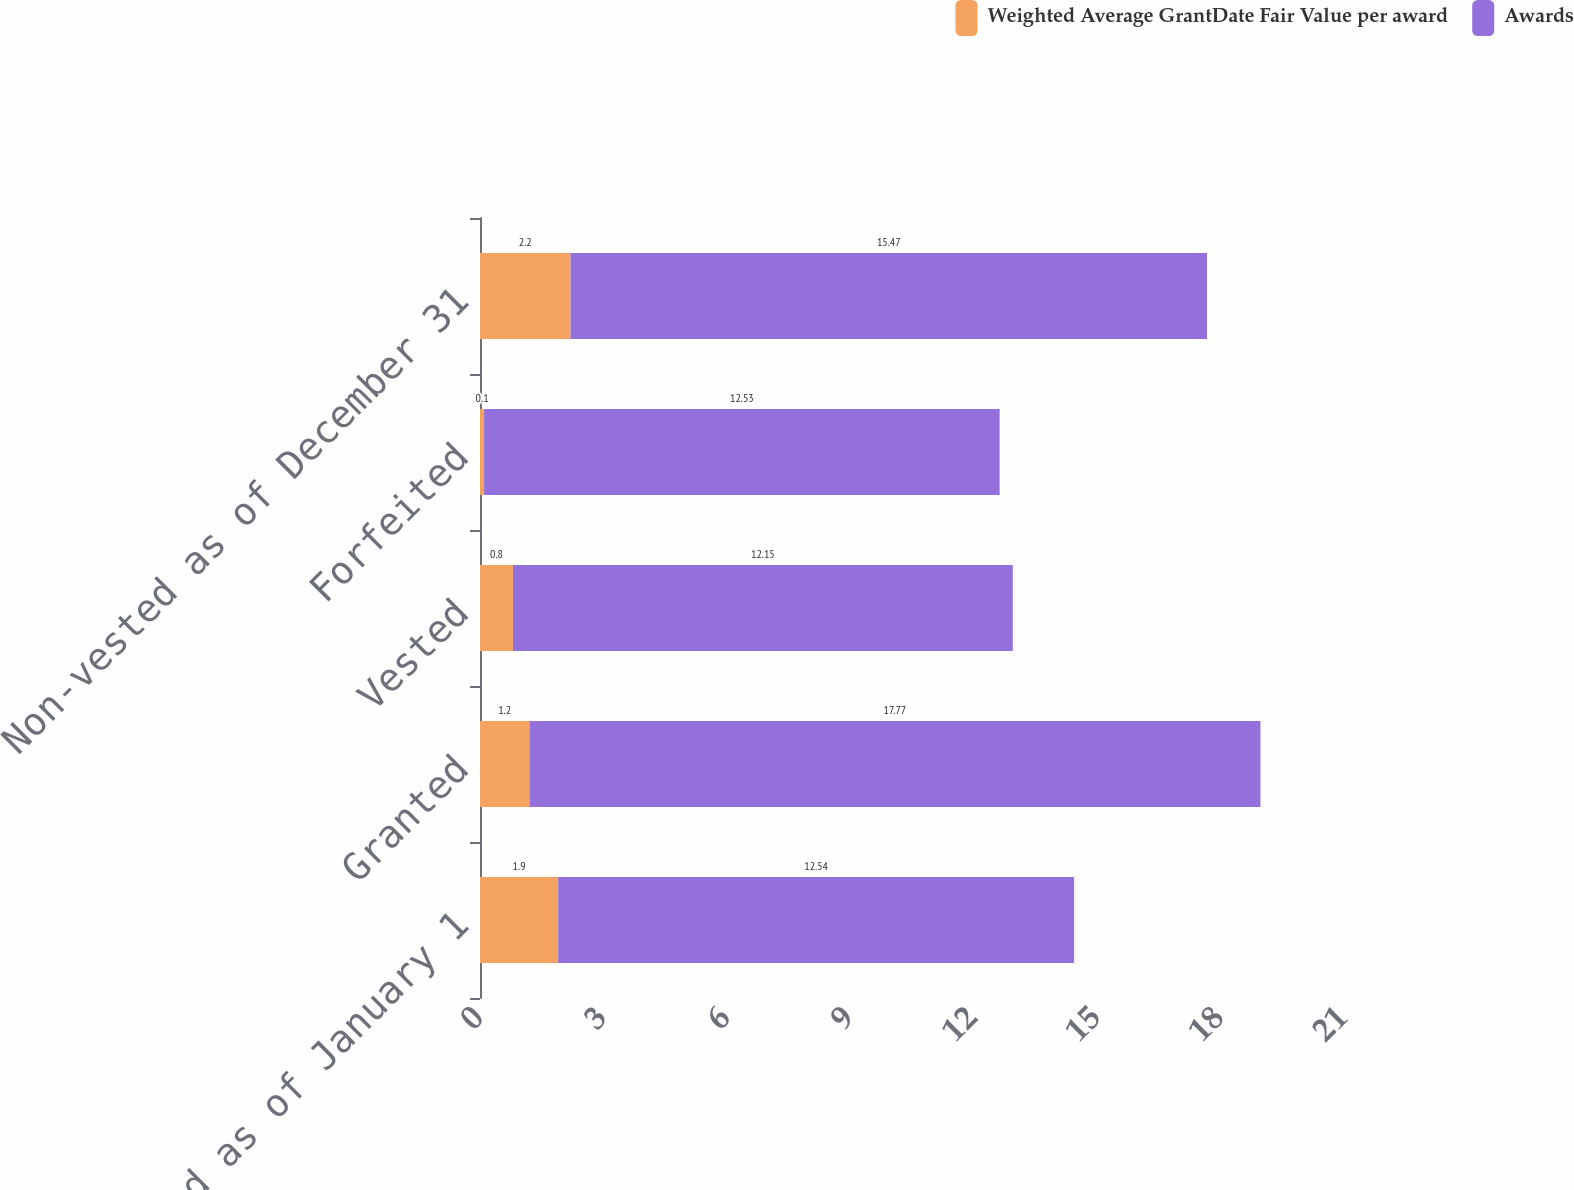Convert chart to OTSL. <chart><loc_0><loc_0><loc_500><loc_500><stacked_bar_chart><ecel><fcel>Non-vested as of January 1<fcel>Granted<fcel>Vested<fcel>Forfeited<fcel>Non-vested as of December 31<nl><fcel>Weighted Average GrantDate Fair Value per award<fcel>1.9<fcel>1.2<fcel>0.8<fcel>0.1<fcel>2.2<nl><fcel>Awards<fcel>12.54<fcel>17.77<fcel>12.15<fcel>12.53<fcel>15.47<nl></chart> 